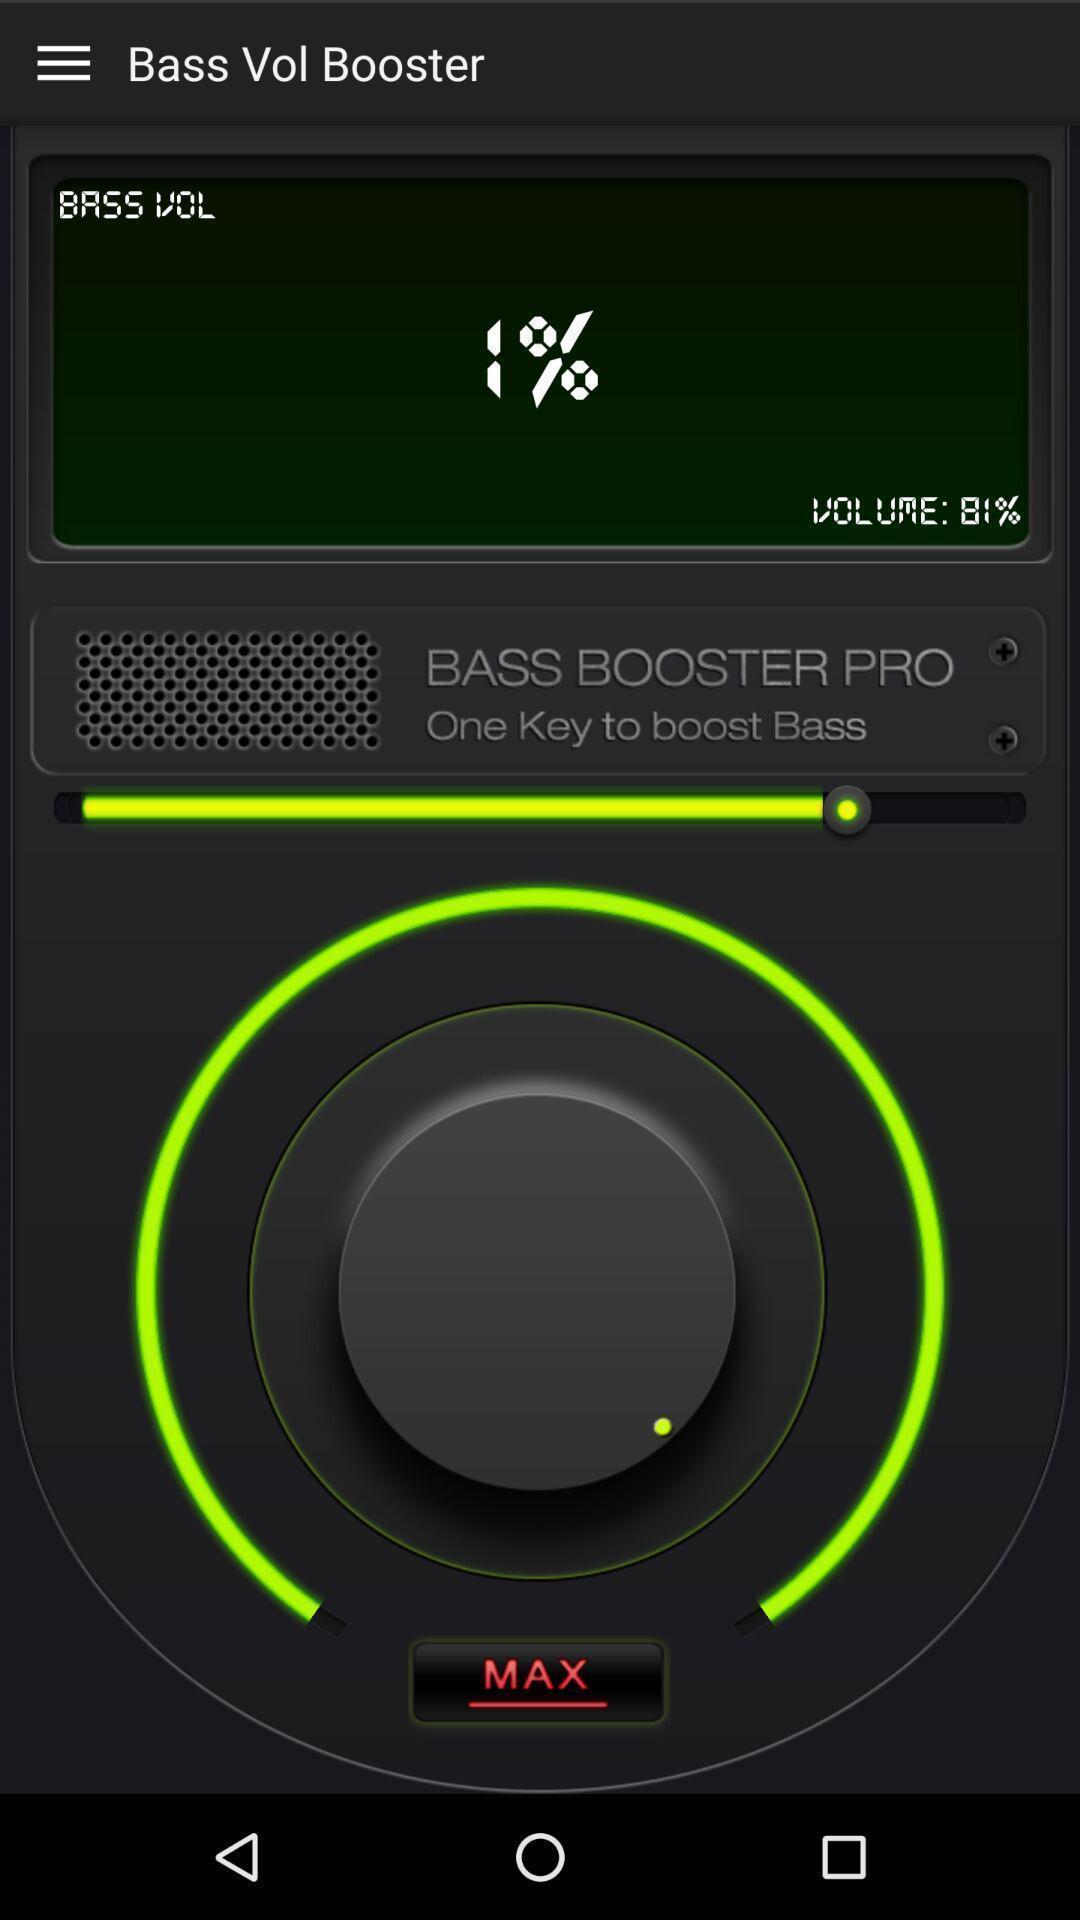What is the overall content of this screenshot? Page screen displaying to increase volume in a music app. 